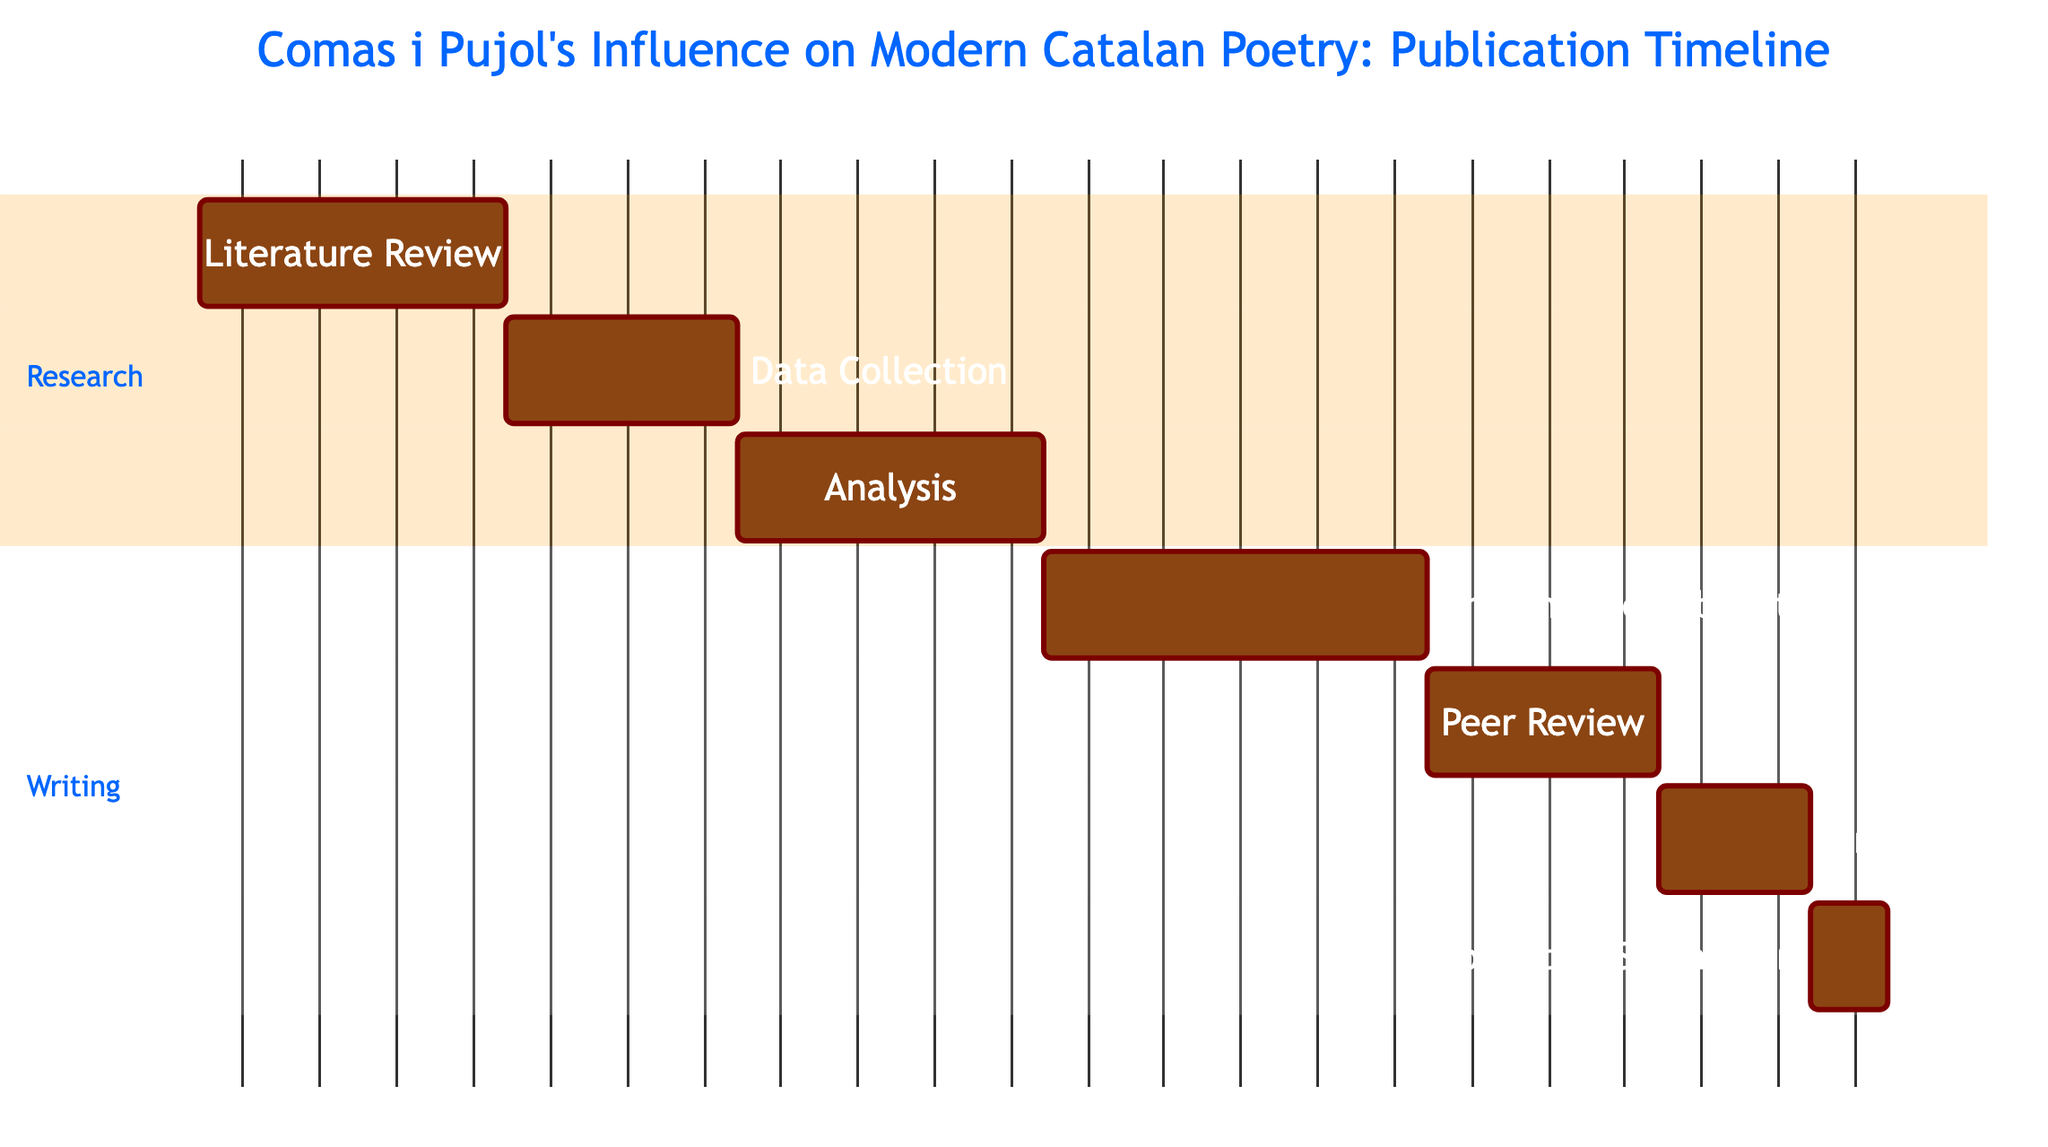What is the duration of the Literature Review task? The Literature Review task is stated to last for 4 weeks according to the duration indicated in the diagram.
Answer: 4 weeks When does the Data Collection task start? According to the timeline provided in the Gantt chart, the Data Collection task starts on November 29, 2023.
Answer: November 29, 2023 How many weeks are allocated for the Drafting the Publication task? The diagram specifies that the Drafting the Publication task is allocated 5 weeks, which is clearly indicated in the duration section for that task.
Answer: 5 weeks What is the immediate task after the Analysis? The diagram shows that the immediate task after Analysis is Drafting the Publication, as the tasks are sequentially listed and the start dates and order confirm this flow.
Answer: Drafting the Publication How many tasks are included in the Research section? By counting the tasks listed in the Research section on the Gantt chart, there are three tasks: Literature Review, Data Collection, and Analysis.
Answer: 3 tasks What is the start date of the Final Edits task? The Gantt chart specifies that the Final Edits task starts on March 13, 2024, which is directly presented under the respective task details.
Answer: March 13, 2024 What is the total duration from Literature Review to Publication Submission? The total duration can be calculated by adding the durations of each task from Literature Review (4 weeks) to Publication Submission (1 week), resulting in a total of 18 weeks. This combines the durations of all tasks sequentially, confirming the timeline.
Answer: 18 weeks What is the task that is being completed right before the Publication Submission? The task that is completed right before Publication Submission is Final Edits, as it directly precedes the final submission task in the outlined order of tasks.
Answer: Final Edits 